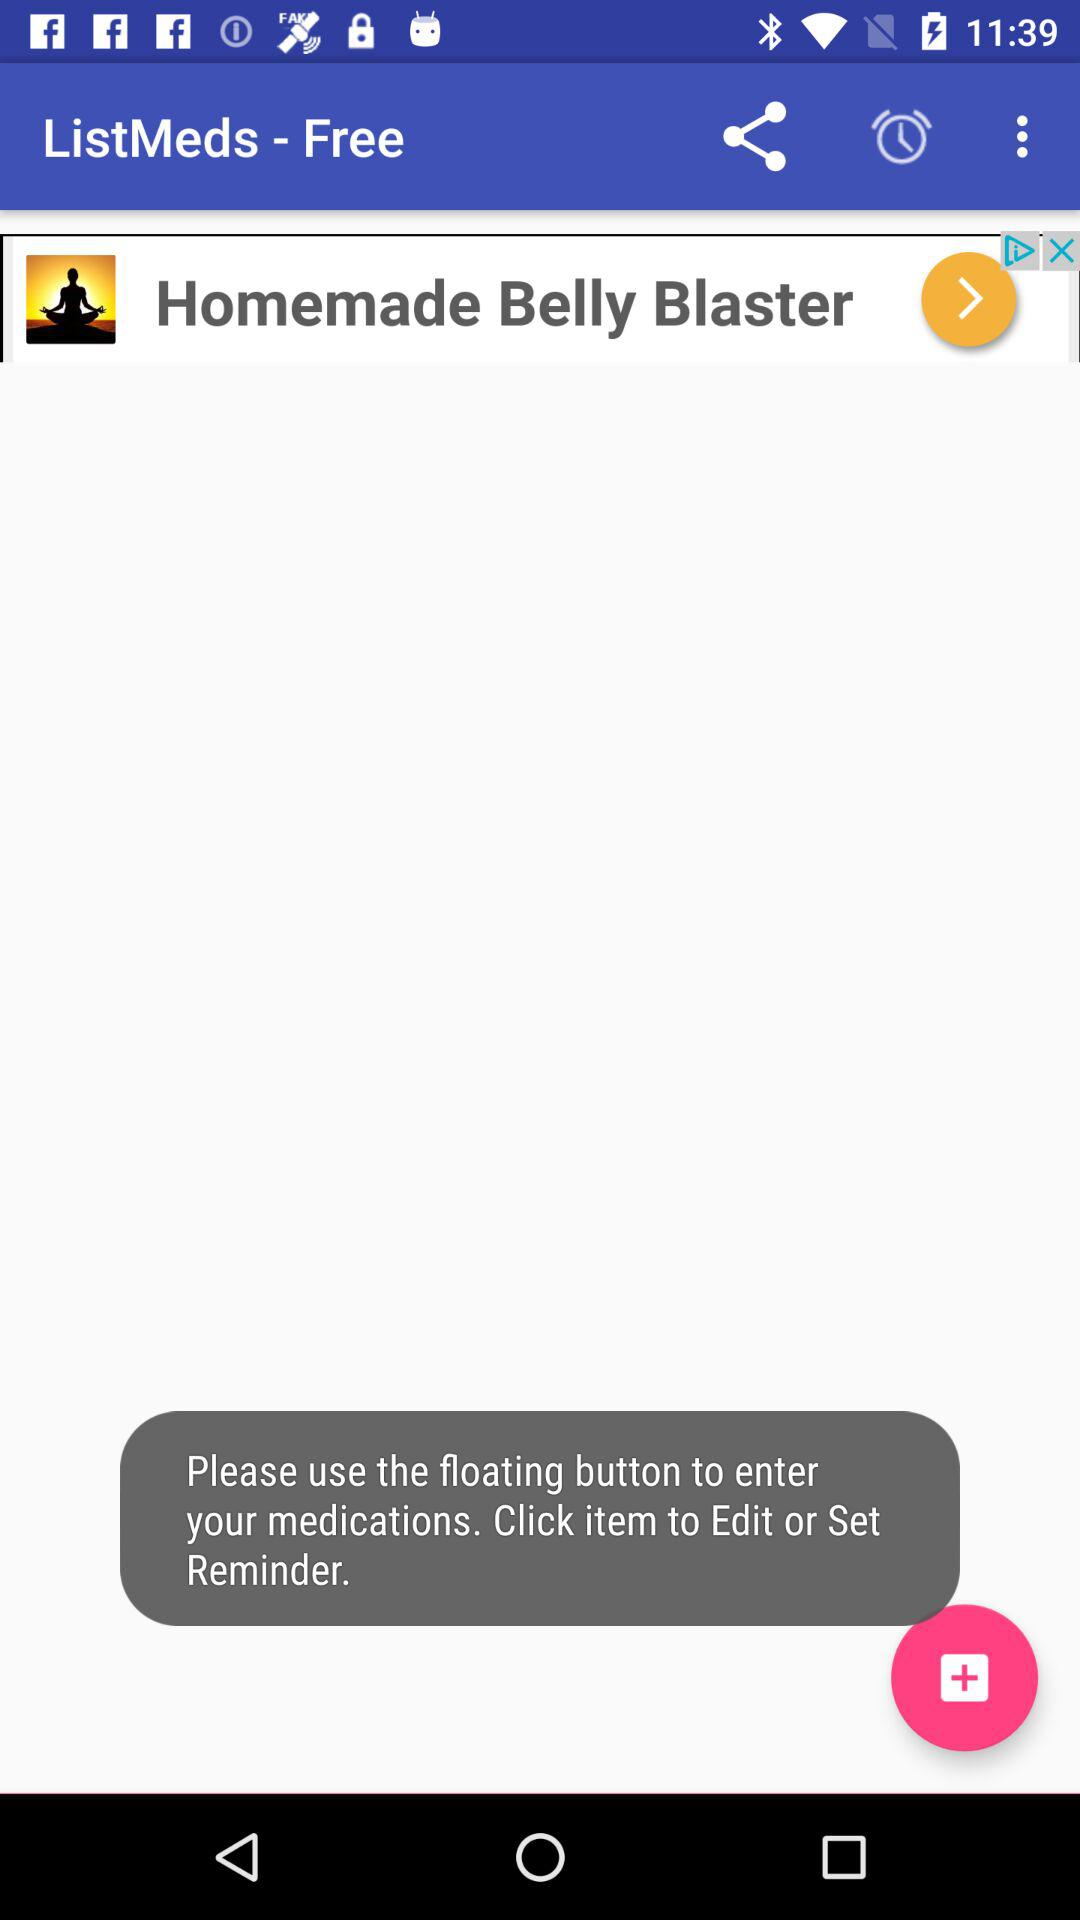What is the application name? The application name is "ListMeds - Free". 